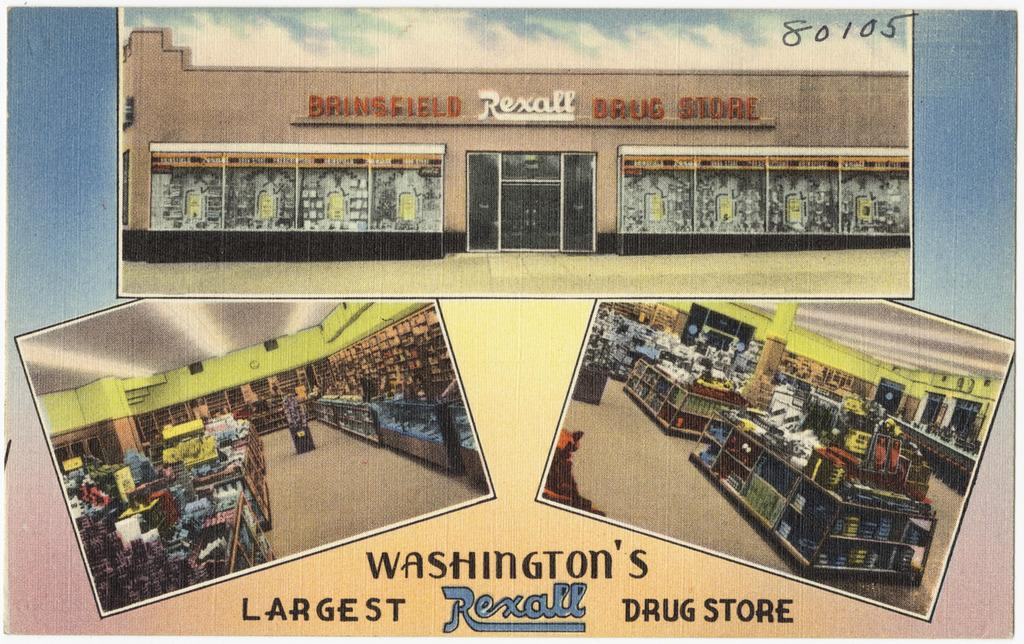<image>
Render a clear and concise summary of the photo. Rexall Drug Store is Washington's largest drug store 